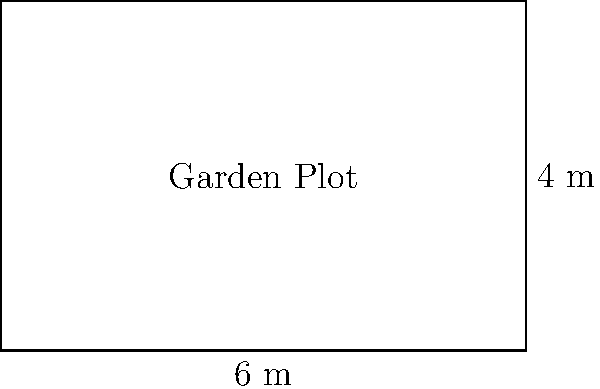You're planning to create a garden plot for your retired carpenter friend to grow vegetables. The rectangular plot measures 6 meters in length and 4 meters in width. What is the total area of this garden plot? To find the area of a rectangular garden plot, we need to multiply its length by its width. Here's how we can calculate it step by step:

1. Identify the given dimensions:
   - Length = 6 meters
   - Width = 4 meters

2. Use the formula for the area of a rectangle:
   $$ \text{Area} = \text{Length} \times \text{Width} $$

3. Substitute the known values into the formula:
   $$ \text{Area} = 6 \text{ m} \times 4 \text{ m} $$

4. Perform the multiplication:
   $$ \text{Area} = 24 \text{ m}^2 $$

Therefore, the total area of the garden plot is 24 square meters.
Answer: $24 \text{ m}^2$ 